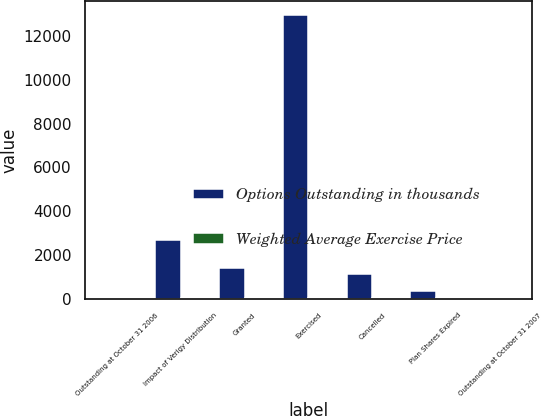Convert chart. <chart><loc_0><loc_0><loc_500><loc_500><stacked_bar_chart><ecel><fcel>Outstanding at October 31 2006<fcel>Impact of Verigy Distribution<fcel>Granted<fcel>Exercised<fcel>Cancelled<fcel>Plan Shares Expired<fcel>Outstanding at October 31 2007<nl><fcel>Options Outstanding in thousands<fcel>36.5<fcel>2705<fcel>1433<fcel>12939<fcel>1135<fcel>356<fcel>36.5<nl><fcel>Weighted Average Exercise Price<fcel>29<fcel>29<fcel>33<fcel>25<fcel>35<fcel>38<fcel>29<nl></chart> 